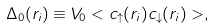Convert formula to latex. <formula><loc_0><loc_0><loc_500><loc_500>\Delta _ { 0 } ( r _ { i } ) \equiv V _ { 0 } < c _ { \uparrow } ( r _ { i } ) c _ { \downarrow } ( r _ { i } ) > ,</formula> 